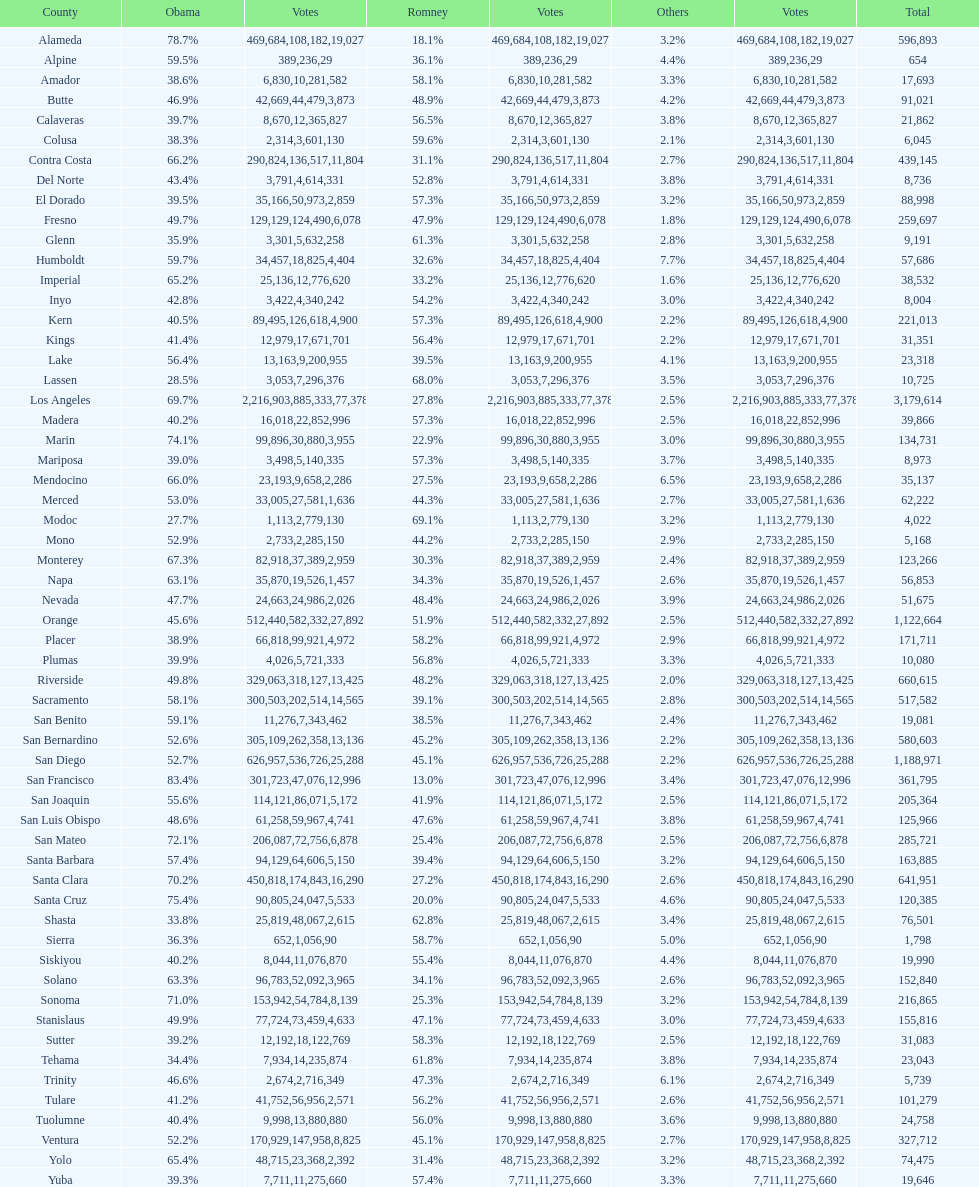Which count registered the minimum number of votes for obama? Modoc. 